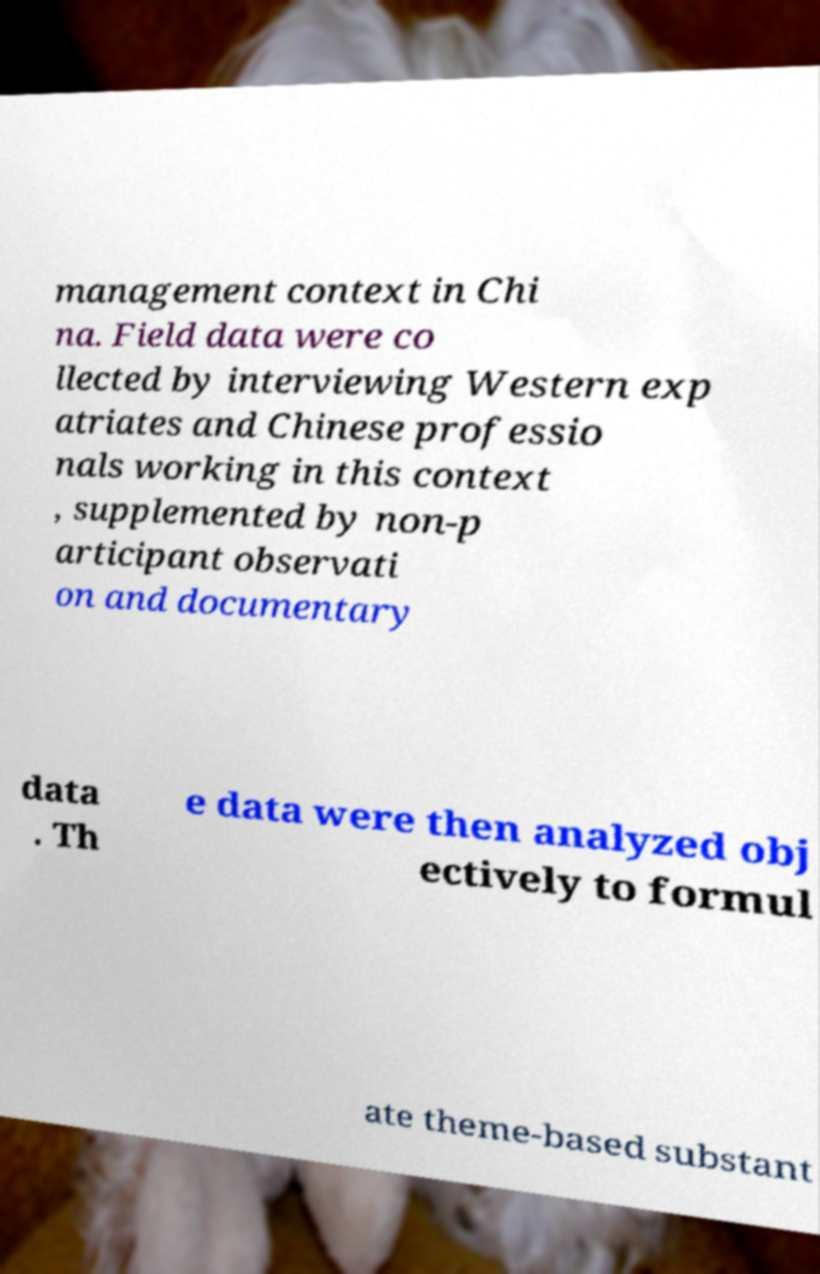Can you read and provide the text displayed in the image?This photo seems to have some interesting text. Can you extract and type it out for me? management context in Chi na. Field data were co llected by interviewing Western exp atriates and Chinese professio nals working in this context , supplemented by non-p articipant observati on and documentary data . Th e data were then analyzed obj ectively to formul ate theme-based substant 